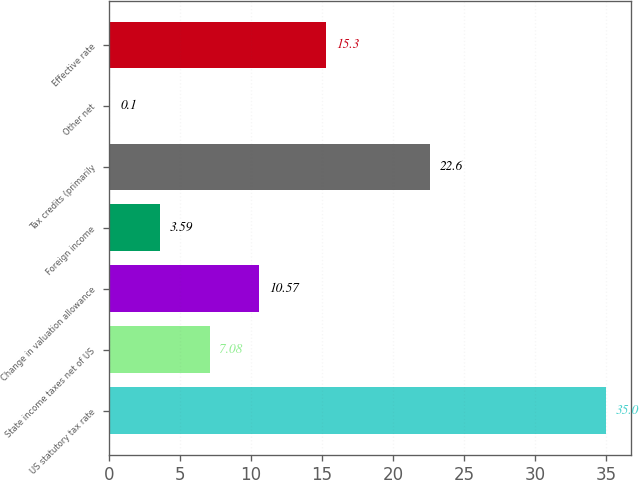Convert chart to OTSL. <chart><loc_0><loc_0><loc_500><loc_500><bar_chart><fcel>US statutory tax rate<fcel>State income taxes net of US<fcel>Change in valuation allowance<fcel>Foreign income<fcel>Tax credits (primarily<fcel>Other net<fcel>Effective rate<nl><fcel>35<fcel>7.08<fcel>10.57<fcel>3.59<fcel>22.6<fcel>0.1<fcel>15.3<nl></chart> 